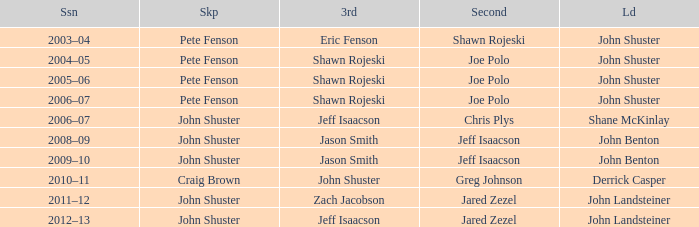Can you parse all the data within this table? {'header': ['Ssn', 'Skp', '3rd', 'Second', 'Ld'], 'rows': [['2003–04', 'Pete Fenson', 'Eric Fenson', 'Shawn Rojeski', 'John Shuster'], ['2004–05', 'Pete Fenson', 'Shawn Rojeski', 'Joe Polo', 'John Shuster'], ['2005–06', 'Pete Fenson', 'Shawn Rojeski', 'Joe Polo', 'John Shuster'], ['2006–07', 'Pete Fenson', 'Shawn Rojeski', 'Joe Polo', 'John Shuster'], ['2006–07', 'John Shuster', 'Jeff Isaacson', 'Chris Plys', 'Shane McKinlay'], ['2008–09', 'John Shuster', 'Jason Smith', 'Jeff Isaacson', 'John Benton'], ['2009–10', 'John Shuster', 'Jason Smith', 'Jeff Isaacson', 'John Benton'], ['2010–11', 'Craig Brown', 'John Shuster', 'Greg Johnson', 'Derrick Casper'], ['2011–12', 'John Shuster', 'Zach Jacobson', 'Jared Zezel', 'John Landsteiner'], ['2012–13', 'John Shuster', 'Jeff Isaacson', 'Jared Zezel', 'John Landsteiner']]} Which season has Zach Jacobson in third? 2011–12. 